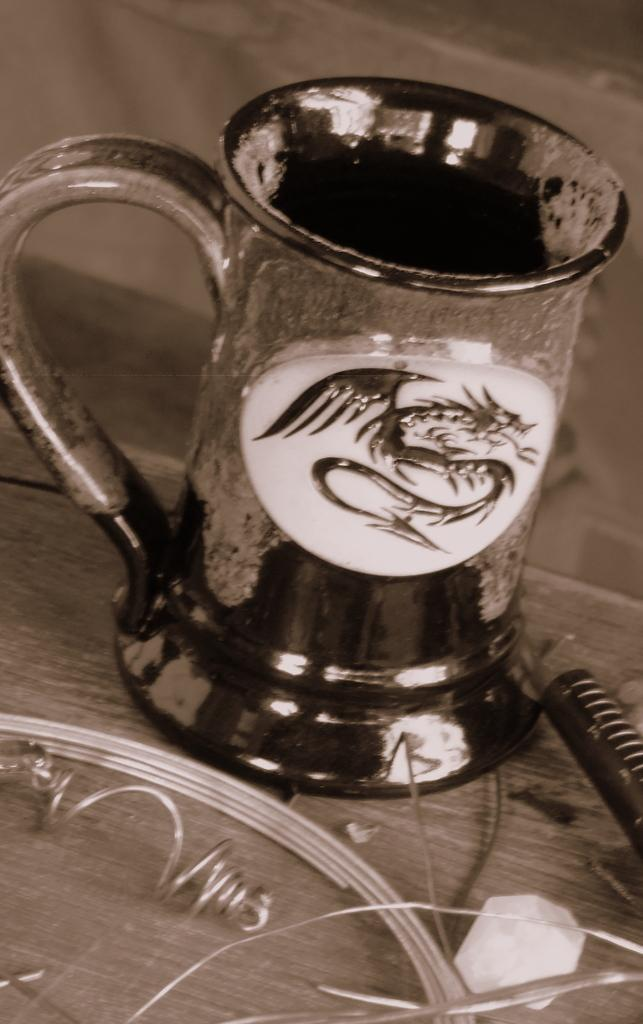What is the color scheme of the image? The image is black and white. What piece of furniture is present at the bottom of the image? There is a table at the bottom of the image. What is placed on the table? There is a cup on the table. Can you describe any other items on the table? There are a few unspecified things on the table. Is there a bottle of water on the table in the image? There is no mention of a bottle of water in the image, so we cannot confirm its presence. Can you see a tiger walking near the table in the image? There is no tiger present in the image; it is a black and white image featuring a table, a cup, and a few unspecified items. 